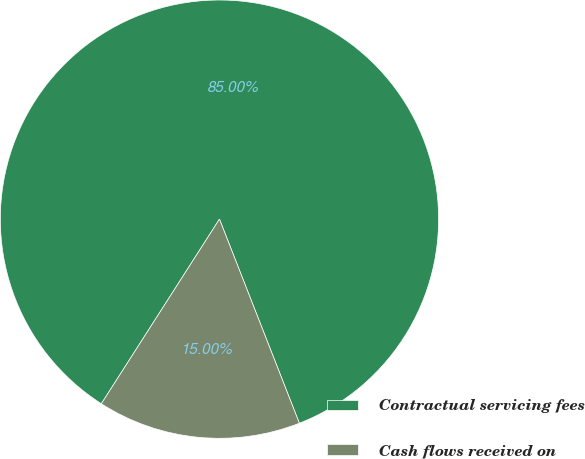Convert chart. <chart><loc_0><loc_0><loc_500><loc_500><pie_chart><fcel>Contractual servicing fees<fcel>Cash flows received on<nl><fcel>85.0%<fcel>15.0%<nl></chart> 